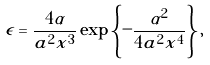<formula> <loc_0><loc_0><loc_500><loc_500>\epsilon = \frac { 4 \alpha } { a ^ { 2 } x ^ { 3 } } \exp \left \{ - \frac { \alpha ^ { 2 } } { 4 a ^ { 2 } x ^ { 4 } } \right \} ,</formula> 